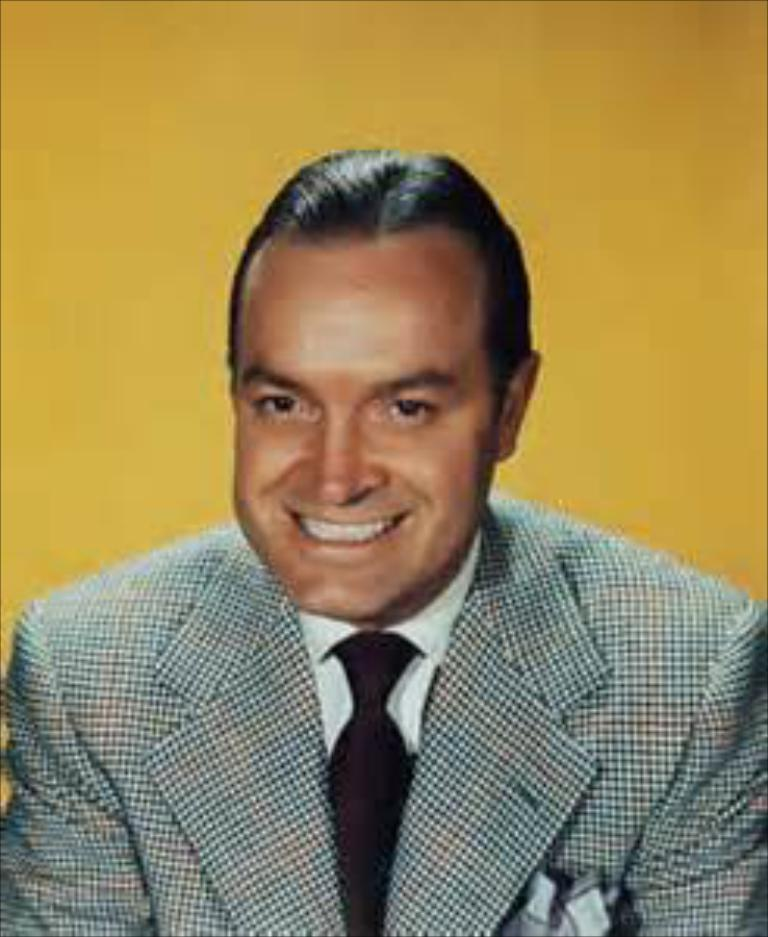Who is present in the image? There is a man in the image. What is the man doing in the image? The man is smiling in the image. What is the man wearing in the image? The man is wearing a suit in the image. What color is the background of the image? The background of the image is yellow. What type of wilderness can be seen in the background of the image? There is no wilderness present in the image; the background is yellow. 